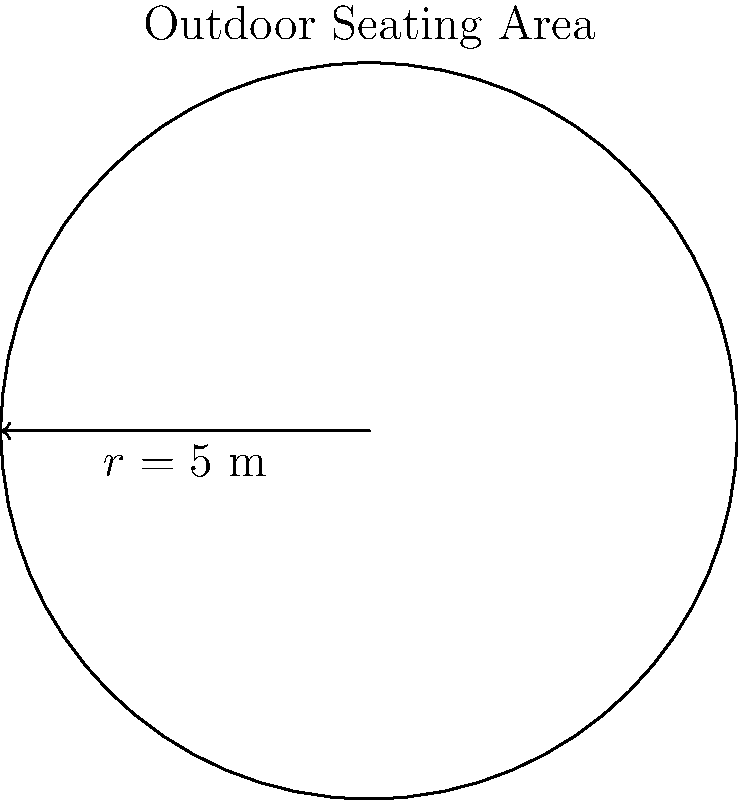You're planning to install a circular outdoor seating area for your restaurant. If the radius of the area is 5 meters, what is the circumference of the seating area? Round your answer to the nearest centimeter. To solve this problem, we'll use the formula for the circumference of a circle and follow these steps:

1) The formula for the circumference of a circle is:
   $$C = 2\pi r$$
   where $C$ is the circumference and $r$ is the radius.

2) We're given that the radius is 5 meters. Let's substitute this into our formula:
   $$C = 2\pi (5)$$

3) Now, let's calculate:
   $$C = 10\pi$$

4) To get a numerical value, we need to use an approximation for $\pi$. Let's use 3.14159:
   $$C \approx 10 * 3.14159 = 31.4159 \text{ meters}$$

5) The question asks for the answer rounded to the nearest centimeter. There are 100 centimeters in a meter, so:
   $$31.4159 \text{ meters} = 3141.59 \text{ centimeters}$$

6) Rounding to the nearest centimeter:
   $$3141.59 \text{ cm} \approx 3141.6 \text{ cm}$$

Therefore, the circumference of the outdoor seating area is approximately 3141.6 cm or 31.42 m.
Answer: 3141.6 cm 